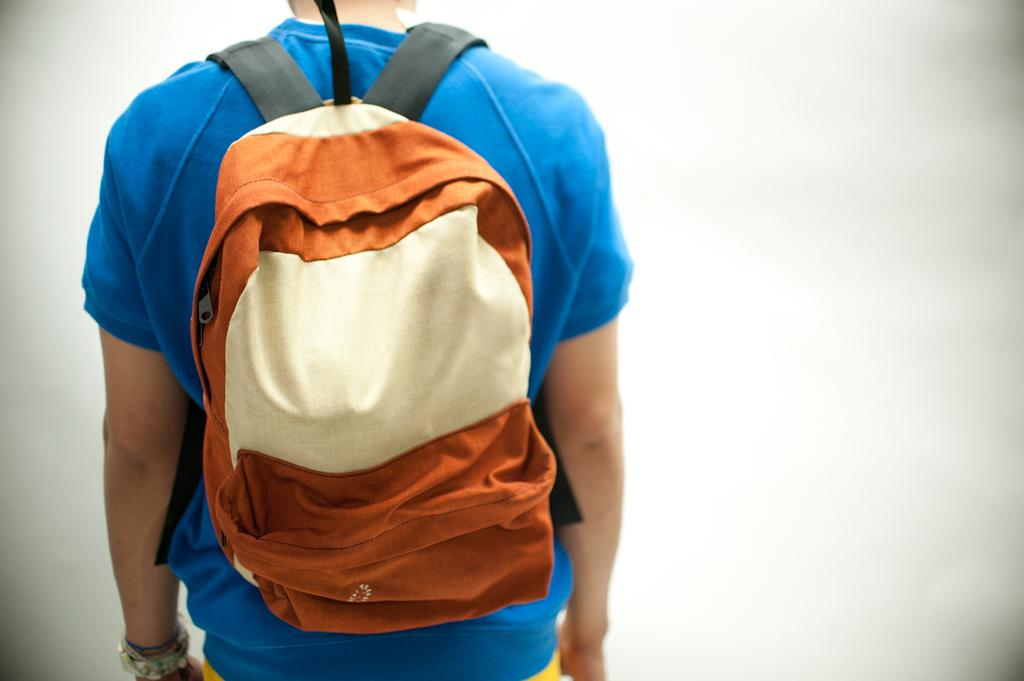What is present in the image? There is a person in the image. What is the person wearing? The person is wearing a backpack. Can you describe the backpack's appearance? The backpack is of orange and cream color. What type of brick is being used to build the moon in the image? There is no moon or brick present in the image; it features a person wearing an orange and cream backpack. 